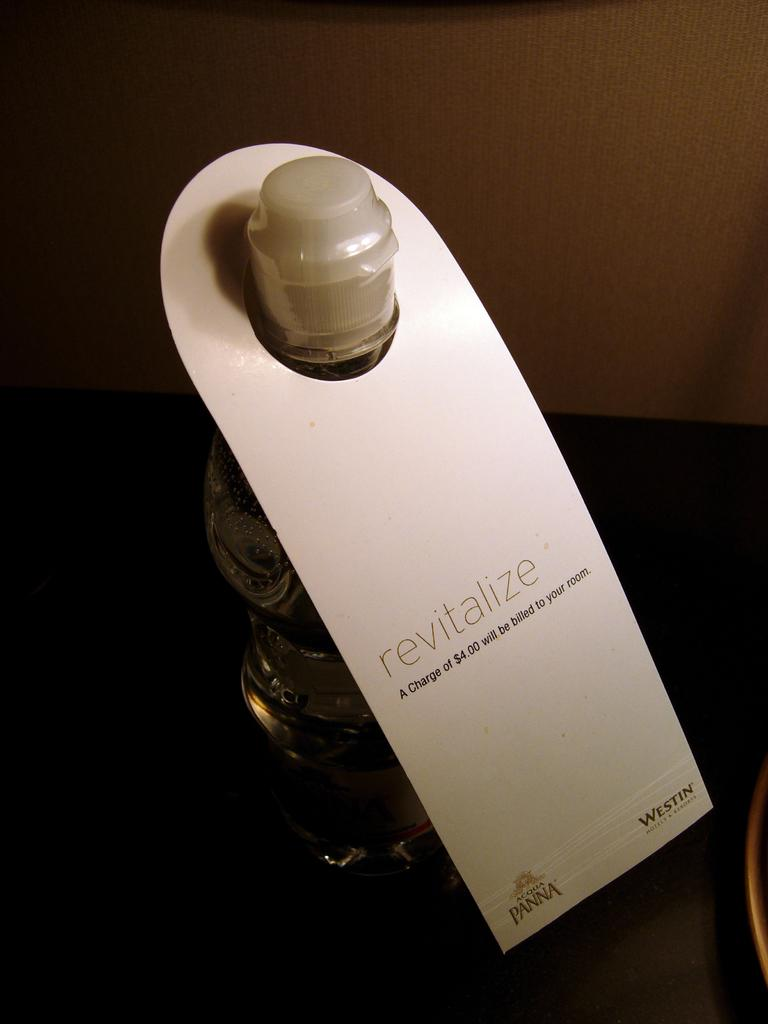<image>
Relay a brief, clear account of the picture shown. a tag around a bottle which has the word revitalize on it 